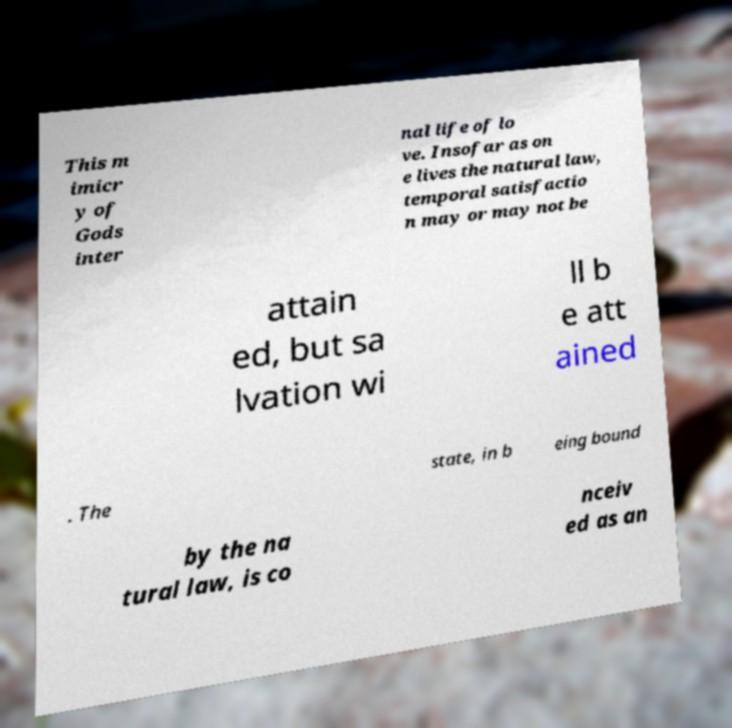Can you read and provide the text displayed in the image?This photo seems to have some interesting text. Can you extract and type it out for me? This m imicr y of Gods inter nal life of lo ve. Insofar as on e lives the natural law, temporal satisfactio n may or may not be attain ed, but sa lvation wi ll b e att ained . The state, in b eing bound by the na tural law, is co nceiv ed as an 